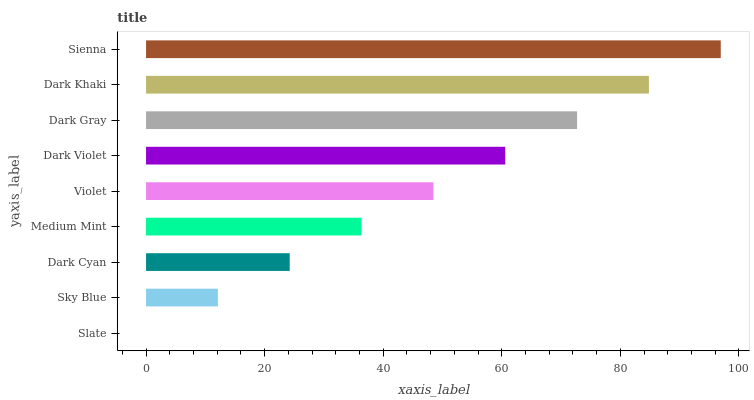Is Slate the minimum?
Answer yes or no. Yes. Is Sienna the maximum?
Answer yes or no. Yes. Is Sky Blue the minimum?
Answer yes or no. No. Is Sky Blue the maximum?
Answer yes or no. No. Is Sky Blue greater than Slate?
Answer yes or no. Yes. Is Slate less than Sky Blue?
Answer yes or no. Yes. Is Slate greater than Sky Blue?
Answer yes or no. No. Is Sky Blue less than Slate?
Answer yes or no. No. Is Violet the high median?
Answer yes or no. Yes. Is Violet the low median?
Answer yes or no. Yes. Is Slate the high median?
Answer yes or no. No. Is Medium Mint the low median?
Answer yes or no. No. 